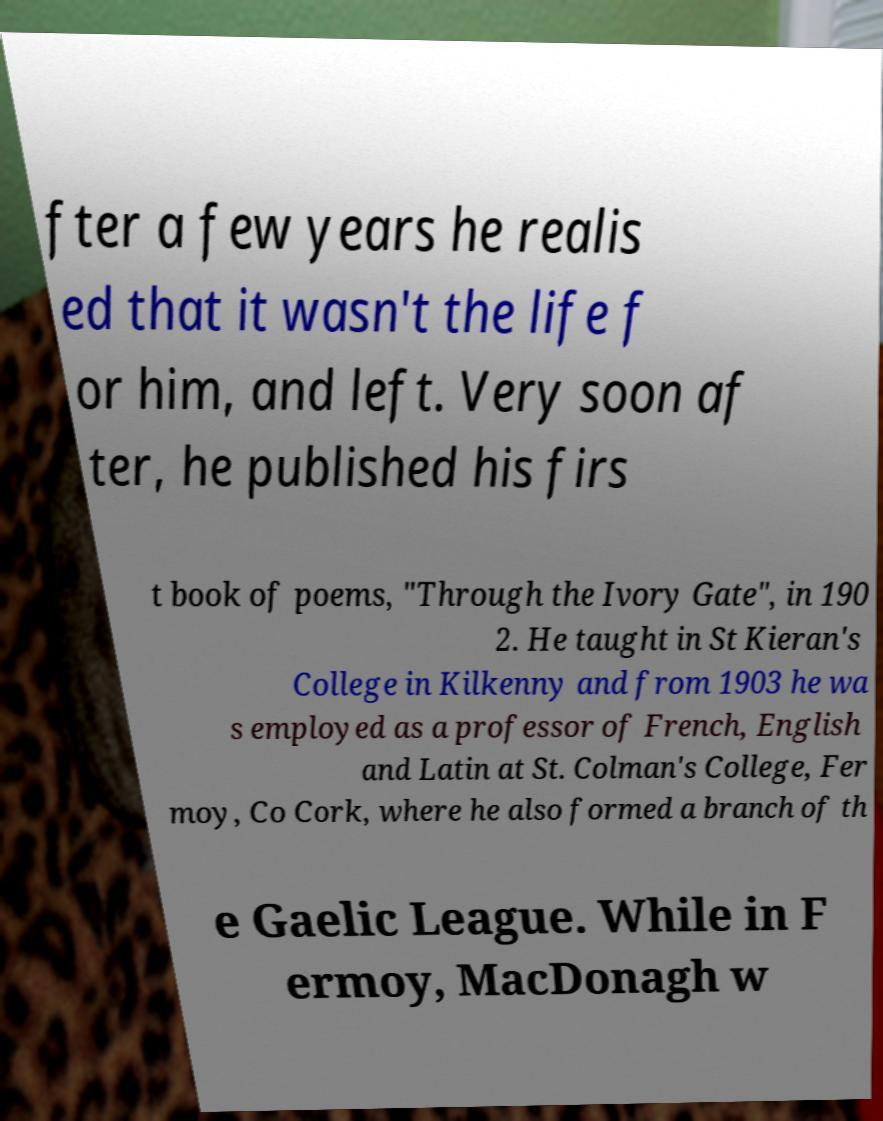Can you accurately transcribe the text from the provided image for me? fter a few years he realis ed that it wasn't the life f or him, and left. Very soon af ter, he published his firs t book of poems, "Through the Ivory Gate", in 190 2. He taught in St Kieran's College in Kilkenny and from 1903 he wa s employed as a professor of French, English and Latin at St. Colman's College, Fer moy, Co Cork, where he also formed a branch of th e Gaelic League. While in F ermoy, MacDonagh w 